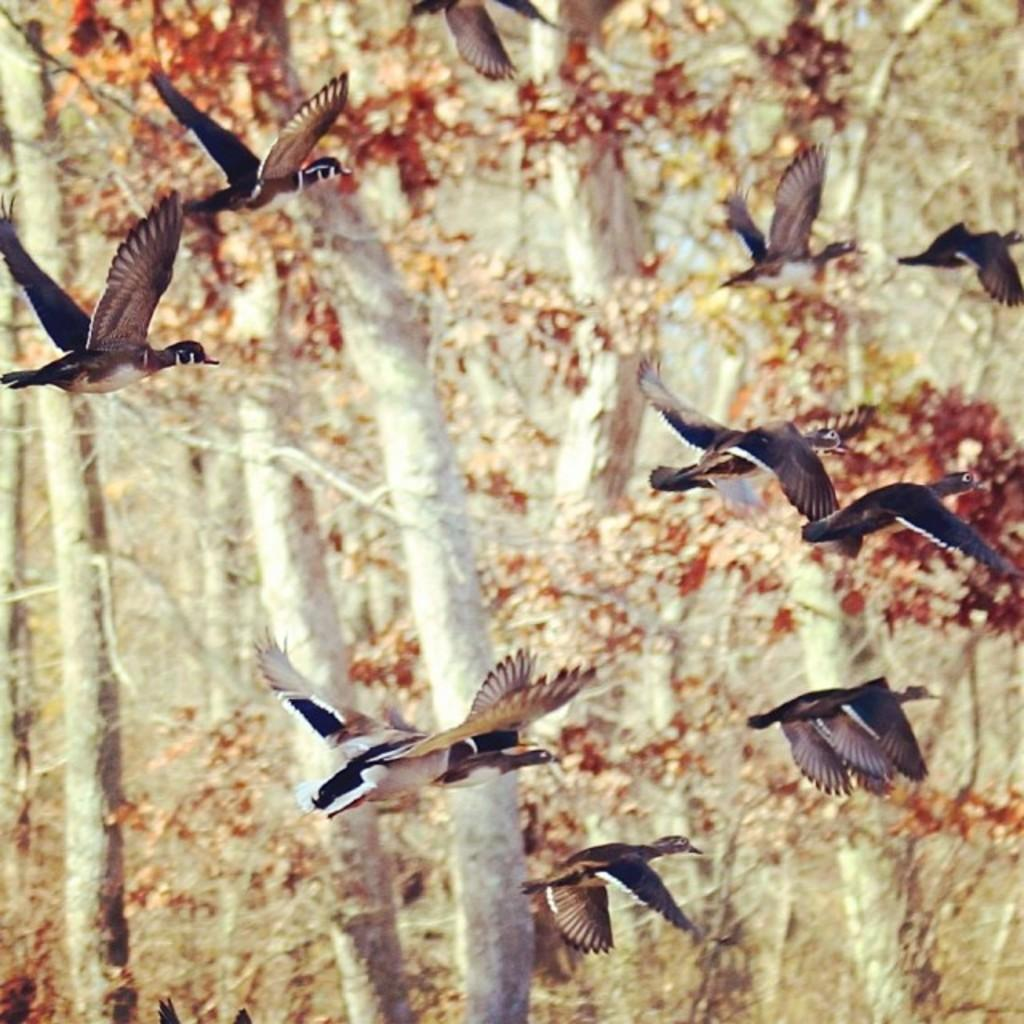What is happening with the birds in the image? The birds are flying in the air in the image. What colors can be seen on the birds? The birds are in black, brown, and white colors. What type of natural environment is visible in the image? There are trees visible in the image. Can you see any matches being used by the birds in the image? There are no matches present in the image, and the birds are not using any. How many cats are visible in the image? There are no cats present in the image. 